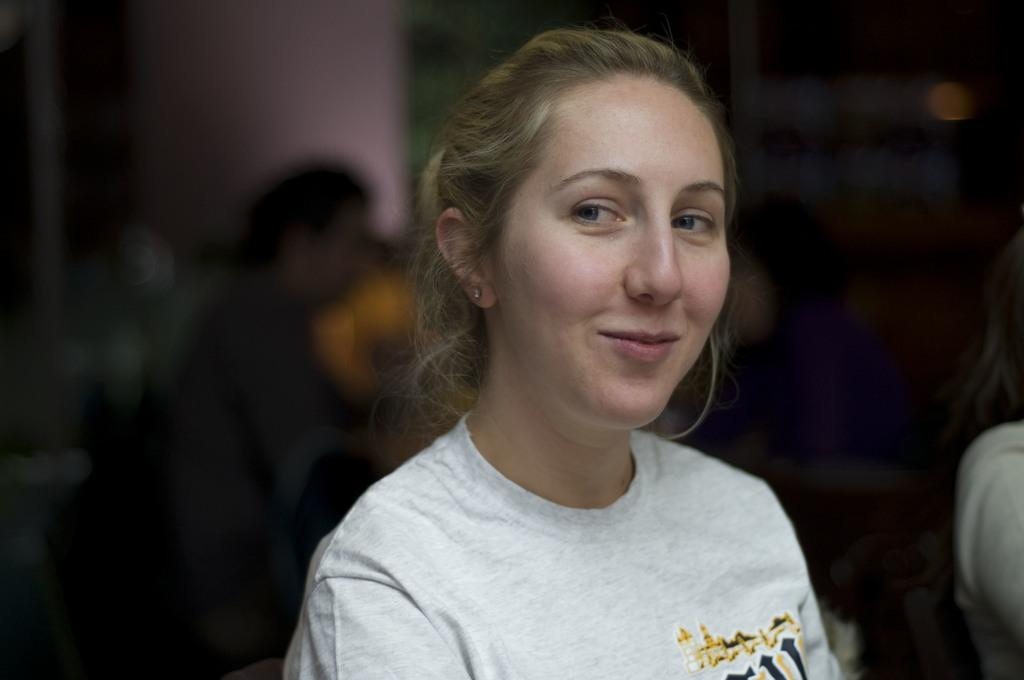Who is the main subject in the foreground of the image? There is a woman in the foreground of the image. What is the woman doing in the image? The woman is smiling. Can you describe the background of the image? The background of the image is blurry. Are there any other people visible in the image? Yes, there are persons in the background of the image. What type of tent can be seen in the image? There is no tent present in the image. Is the sand visible in the image? There is no sand visible in the image. 